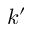<formula> <loc_0><loc_0><loc_500><loc_500>k ^ { \prime }</formula> 